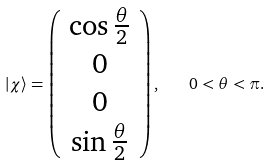<formula> <loc_0><loc_0><loc_500><loc_500>\left | \chi \right \rangle = \left ( { \begin{array} { c } \cos \frac { \theta } { 2 } \\ 0 \\ 0 \\ \sin \frac { \theta } { 2 } \\ \end{array} } \right ) , \quad 0 < \theta < \pi .</formula> 